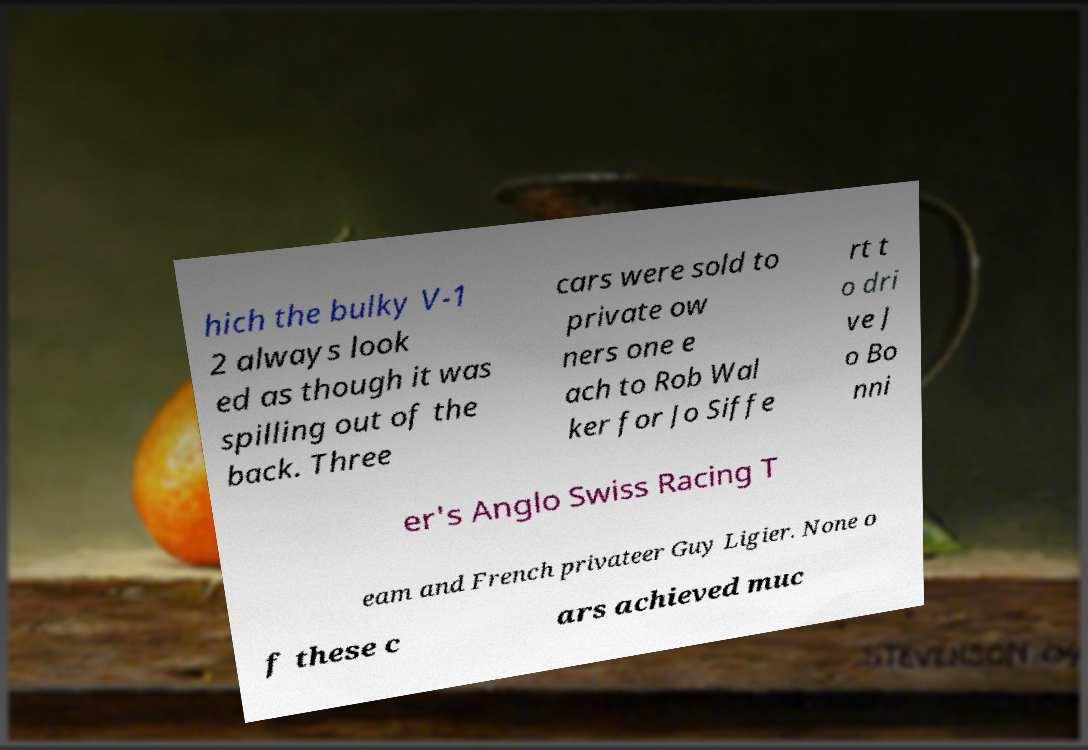Could you extract and type out the text from this image? hich the bulky V-1 2 always look ed as though it was spilling out of the back. Three cars were sold to private ow ners one e ach to Rob Wal ker for Jo Siffe rt t o dri ve J o Bo nni er's Anglo Swiss Racing T eam and French privateer Guy Ligier. None o f these c ars achieved muc 